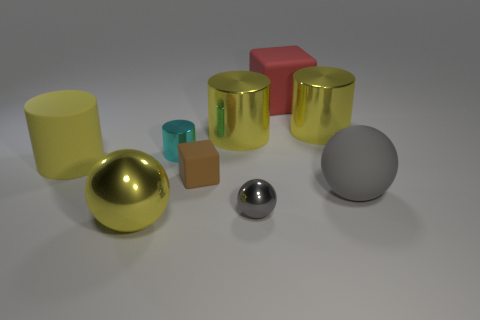What number of shiny things are either small blue spheres or small gray objects?
Your answer should be very brief. 1. How big is the yellow matte cylinder?
Your answer should be very brief. Large. Does the cyan shiny cylinder have the same size as the brown thing?
Your response must be concise. Yes. What is the material of the large sphere to the left of the small cyan metal object?
Ensure brevity in your answer.  Metal. There is another small thing that is the same shape as the red object; what material is it?
Offer a very short reply. Rubber. There is a small gray ball on the right side of the cyan shiny cylinder; are there any large metal objects behind it?
Give a very brief answer. Yes. Is the shape of the small gray shiny object the same as the cyan thing?
Keep it short and to the point. No. There is a brown thing that is made of the same material as the red thing; what is its shape?
Provide a short and direct response. Cube. There is a block that is to the right of the tiny sphere; is its size the same as the shiny cylinder to the left of the brown object?
Make the answer very short. No. Are there more objects that are on the left side of the yellow metallic ball than metal cylinders that are to the right of the tiny rubber block?
Offer a very short reply. No. 